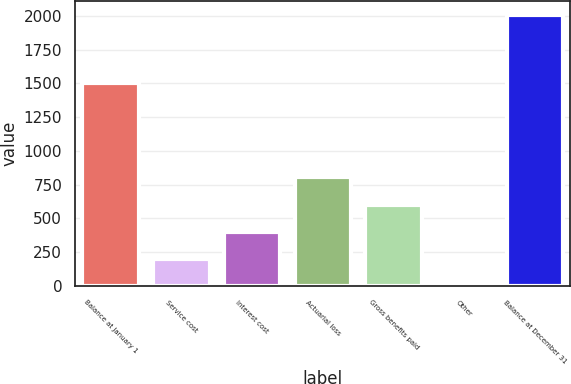Convert chart. <chart><loc_0><loc_0><loc_500><loc_500><bar_chart><fcel>Balance at January 1<fcel>Service cost<fcel>Interest cost<fcel>Actuarial loss<fcel>Gross benefits paid<fcel>Other<fcel>Balance at December 31<nl><fcel>1505<fcel>201.5<fcel>402<fcel>803<fcel>602.5<fcel>1<fcel>2006<nl></chart> 